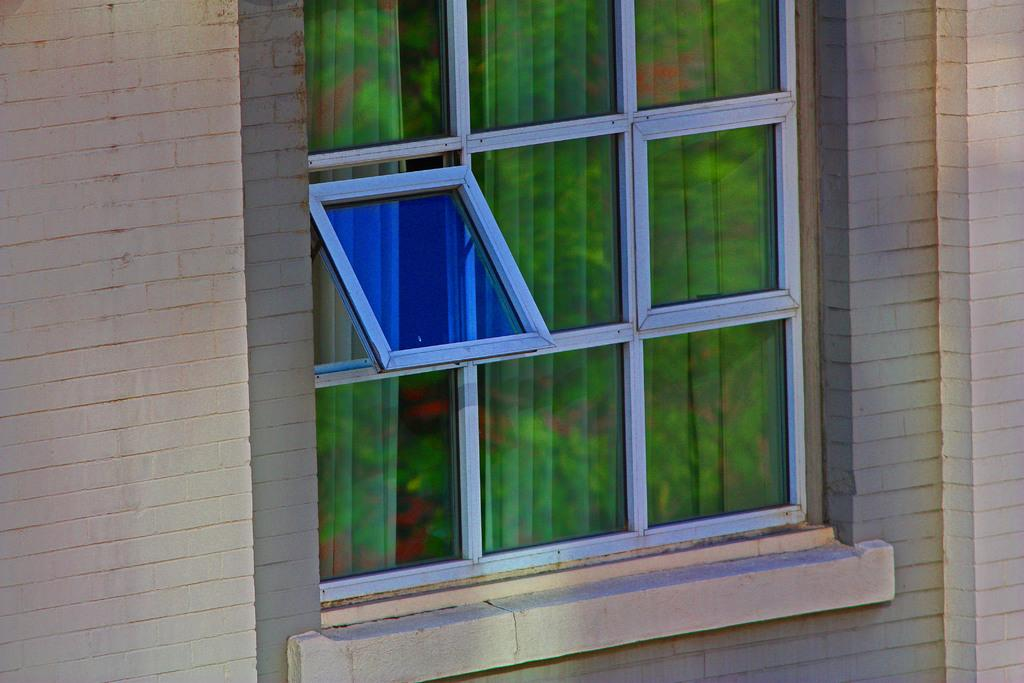What type of structure can be seen in the image? There is a wall in the image. What is present on the wall? There is a glass window in the image. Is there any window treatment visible? Yes, there is a curtain associated with the window. How many chairs can be seen in the image? There are no chairs present in the image. What role does the dad play in the image? There is no dad present in the image. 